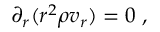<formula> <loc_0><loc_0><loc_500><loc_500>\partial _ { r } ( r ^ { 2 } \rho v _ { r } ) = 0 \ ,</formula> 